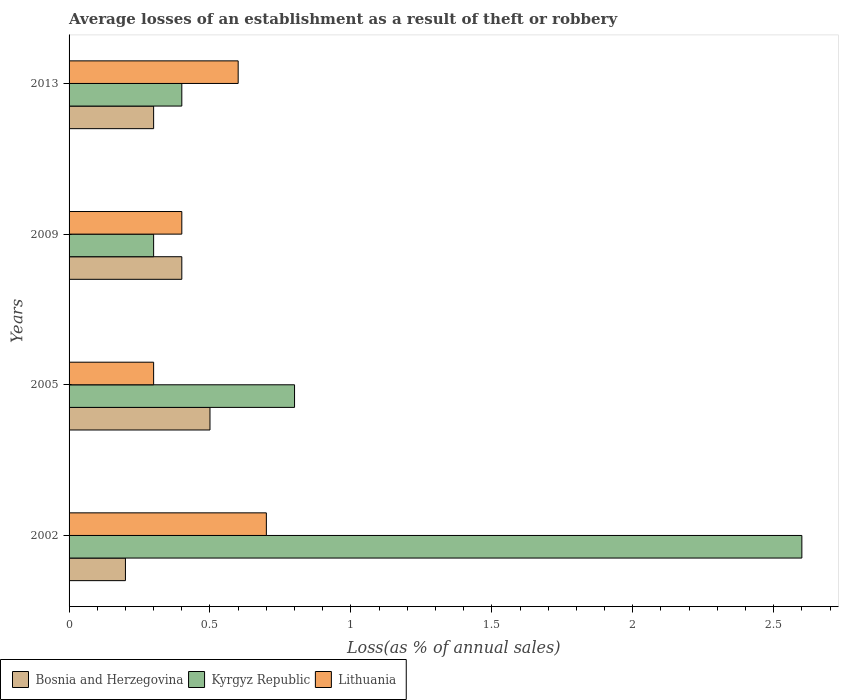How many different coloured bars are there?
Provide a short and direct response. 3. How many groups of bars are there?
Your answer should be compact. 4. Are the number of bars per tick equal to the number of legend labels?
Offer a terse response. Yes. Are the number of bars on each tick of the Y-axis equal?
Your response must be concise. Yes. What is the label of the 1st group of bars from the top?
Provide a succinct answer. 2013. What is the average losses of an establishment in Kyrgyz Republic in 2005?
Make the answer very short. 0.8. What is the difference between the average losses of an establishment in Bosnia and Herzegovina in 2005 and that in 2013?
Give a very brief answer. 0.2. What is the difference between the average losses of an establishment in Kyrgyz Republic in 2009 and the average losses of an establishment in Bosnia and Herzegovina in 2002?
Ensure brevity in your answer.  0.1. What is the average average losses of an establishment in Kyrgyz Republic per year?
Make the answer very short. 1.03. In the year 2009, what is the difference between the average losses of an establishment in Kyrgyz Republic and average losses of an establishment in Lithuania?
Offer a very short reply. -0.1. In how many years, is the average losses of an establishment in Kyrgyz Republic greater than 0.7 %?
Offer a terse response. 2. Is the average losses of an establishment in Lithuania in 2002 less than that in 2009?
Offer a terse response. No. What is the difference between the highest and the second highest average losses of an establishment in Lithuania?
Your response must be concise. 0.1. What is the difference between the highest and the lowest average losses of an establishment in Bosnia and Herzegovina?
Offer a terse response. 0.3. In how many years, is the average losses of an establishment in Bosnia and Herzegovina greater than the average average losses of an establishment in Bosnia and Herzegovina taken over all years?
Offer a terse response. 2. Is the sum of the average losses of an establishment in Lithuania in 2002 and 2009 greater than the maximum average losses of an establishment in Bosnia and Herzegovina across all years?
Provide a succinct answer. Yes. What does the 3rd bar from the top in 2013 represents?
Make the answer very short. Bosnia and Herzegovina. What does the 1st bar from the bottom in 2013 represents?
Your response must be concise. Bosnia and Herzegovina. How many bars are there?
Make the answer very short. 12. How many years are there in the graph?
Your response must be concise. 4. Are the values on the major ticks of X-axis written in scientific E-notation?
Make the answer very short. No. Does the graph contain any zero values?
Ensure brevity in your answer.  No. Does the graph contain grids?
Provide a short and direct response. No. Where does the legend appear in the graph?
Provide a succinct answer. Bottom left. How many legend labels are there?
Give a very brief answer. 3. How are the legend labels stacked?
Provide a succinct answer. Horizontal. What is the title of the graph?
Your response must be concise. Average losses of an establishment as a result of theft or robbery. What is the label or title of the X-axis?
Make the answer very short. Loss(as % of annual sales). What is the label or title of the Y-axis?
Make the answer very short. Years. What is the Loss(as % of annual sales) in Bosnia and Herzegovina in 2002?
Offer a very short reply. 0.2. What is the Loss(as % of annual sales) in Kyrgyz Republic in 2002?
Make the answer very short. 2.6. What is the Loss(as % of annual sales) in Kyrgyz Republic in 2005?
Make the answer very short. 0.8. What is the Loss(as % of annual sales) of Lithuania in 2005?
Provide a succinct answer. 0.3. What is the Loss(as % of annual sales) in Bosnia and Herzegovina in 2009?
Offer a very short reply. 0.4. What is the Loss(as % of annual sales) in Kyrgyz Republic in 2009?
Offer a very short reply. 0.3. What is the Loss(as % of annual sales) of Lithuania in 2009?
Provide a succinct answer. 0.4. What is the Loss(as % of annual sales) of Bosnia and Herzegovina in 2013?
Your answer should be very brief. 0.3. What is the Loss(as % of annual sales) in Lithuania in 2013?
Make the answer very short. 0.6. Across all years, what is the maximum Loss(as % of annual sales) of Bosnia and Herzegovina?
Your answer should be very brief. 0.5. Across all years, what is the maximum Loss(as % of annual sales) of Kyrgyz Republic?
Your answer should be very brief. 2.6. Across all years, what is the maximum Loss(as % of annual sales) in Lithuania?
Offer a very short reply. 0.7. Across all years, what is the minimum Loss(as % of annual sales) of Lithuania?
Make the answer very short. 0.3. What is the total Loss(as % of annual sales) of Kyrgyz Republic in the graph?
Your answer should be very brief. 4.1. What is the total Loss(as % of annual sales) in Lithuania in the graph?
Your answer should be very brief. 2. What is the difference between the Loss(as % of annual sales) of Kyrgyz Republic in 2002 and that in 2005?
Give a very brief answer. 1.8. What is the difference between the Loss(as % of annual sales) in Bosnia and Herzegovina in 2002 and that in 2009?
Ensure brevity in your answer.  -0.2. What is the difference between the Loss(as % of annual sales) in Kyrgyz Republic in 2002 and that in 2009?
Offer a terse response. 2.3. What is the difference between the Loss(as % of annual sales) in Lithuania in 2002 and that in 2009?
Provide a succinct answer. 0.3. What is the difference between the Loss(as % of annual sales) in Lithuania in 2002 and that in 2013?
Give a very brief answer. 0.1. What is the difference between the Loss(as % of annual sales) of Bosnia and Herzegovina in 2005 and that in 2009?
Offer a very short reply. 0.1. What is the difference between the Loss(as % of annual sales) in Lithuania in 2005 and that in 2009?
Keep it short and to the point. -0.1. What is the difference between the Loss(as % of annual sales) of Kyrgyz Republic in 2005 and that in 2013?
Offer a terse response. 0.4. What is the difference between the Loss(as % of annual sales) of Lithuania in 2009 and that in 2013?
Provide a short and direct response. -0.2. What is the difference between the Loss(as % of annual sales) in Bosnia and Herzegovina in 2002 and the Loss(as % of annual sales) in Kyrgyz Republic in 2005?
Provide a succinct answer. -0.6. What is the difference between the Loss(as % of annual sales) of Kyrgyz Republic in 2002 and the Loss(as % of annual sales) of Lithuania in 2005?
Provide a short and direct response. 2.3. What is the difference between the Loss(as % of annual sales) of Bosnia and Herzegovina in 2002 and the Loss(as % of annual sales) of Lithuania in 2009?
Offer a very short reply. -0.2. What is the difference between the Loss(as % of annual sales) of Kyrgyz Republic in 2002 and the Loss(as % of annual sales) of Lithuania in 2013?
Give a very brief answer. 2. What is the difference between the Loss(as % of annual sales) of Bosnia and Herzegovina in 2005 and the Loss(as % of annual sales) of Kyrgyz Republic in 2009?
Offer a terse response. 0.2. What is the difference between the Loss(as % of annual sales) in Bosnia and Herzegovina in 2005 and the Loss(as % of annual sales) in Lithuania in 2009?
Your answer should be compact. 0.1. What is the difference between the Loss(as % of annual sales) in Kyrgyz Republic in 2005 and the Loss(as % of annual sales) in Lithuania in 2009?
Make the answer very short. 0.4. What is the difference between the Loss(as % of annual sales) in Bosnia and Herzegovina in 2005 and the Loss(as % of annual sales) in Kyrgyz Republic in 2013?
Offer a very short reply. 0.1. What is the average Loss(as % of annual sales) in Bosnia and Herzegovina per year?
Your answer should be very brief. 0.35. What is the average Loss(as % of annual sales) in Lithuania per year?
Make the answer very short. 0.5. In the year 2002, what is the difference between the Loss(as % of annual sales) of Kyrgyz Republic and Loss(as % of annual sales) of Lithuania?
Give a very brief answer. 1.9. In the year 2005, what is the difference between the Loss(as % of annual sales) in Bosnia and Herzegovina and Loss(as % of annual sales) in Kyrgyz Republic?
Provide a short and direct response. -0.3. In the year 2005, what is the difference between the Loss(as % of annual sales) in Bosnia and Herzegovina and Loss(as % of annual sales) in Lithuania?
Your response must be concise. 0.2. In the year 2009, what is the difference between the Loss(as % of annual sales) in Bosnia and Herzegovina and Loss(as % of annual sales) in Kyrgyz Republic?
Offer a terse response. 0.1. In the year 2009, what is the difference between the Loss(as % of annual sales) in Bosnia and Herzegovina and Loss(as % of annual sales) in Lithuania?
Offer a very short reply. 0. In the year 2009, what is the difference between the Loss(as % of annual sales) of Kyrgyz Republic and Loss(as % of annual sales) of Lithuania?
Keep it short and to the point. -0.1. In the year 2013, what is the difference between the Loss(as % of annual sales) of Bosnia and Herzegovina and Loss(as % of annual sales) of Kyrgyz Republic?
Ensure brevity in your answer.  -0.1. What is the ratio of the Loss(as % of annual sales) of Bosnia and Herzegovina in 2002 to that in 2005?
Offer a terse response. 0.4. What is the ratio of the Loss(as % of annual sales) in Lithuania in 2002 to that in 2005?
Offer a very short reply. 2.33. What is the ratio of the Loss(as % of annual sales) in Kyrgyz Republic in 2002 to that in 2009?
Keep it short and to the point. 8.67. What is the ratio of the Loss(as % of annual sales) in Lithuania in 2002 to that in 2009?
Your response must be concise. 1.75. What is the ratio of the Loss(as % of annual sales) of Lithuania in 2002 to that in 2013?
Your answer should be very brief. 1.17. What is the ratio of the Loss(as % of annual sales) of Kyrgyz Republic in 2005 to that in 2009?
Offer a very short reply. 2.67. What is the ratio of the Loss(as % of annual sales) in Bosnia and Herzegovina in 2005 to that in 2013?
Offer a terse response. 1.67. What is the ratio of the Loss(as % of annual sales) of Kyrgyz Republic in 2005 to that in 2013?
Give a very brief answer. 2. What is the ratio of the Loss(as % of annual sales) in Lithuania in 2005 to that in 2013?
Make the answer very short. 0.5. What is the ratio of the Loss(as % of annual sales) in Kyrgyz Republic in 2009 to that in 2013?
Make the answer very short. 0.75. What is the difference between the highest and the second highest Loss(as % of annual sales) of Lithuania?
Offer a very short reply. 0.1. What is the difference between the highest and the lowest Loss(as % of annual sales) in Lithuania?
Ensure brevity in your answer.  0.4. 